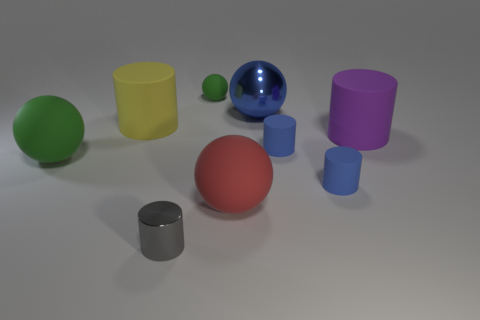Could you tell me the number of cylindrical objects and describe their appearance? There are five cylindrical objects in the image, each displaying a circular base and elongated sides. The cylinders vary in color - one is gray, one is yellow, one is purple, and two are blue, with one of the blue cylinders appearing in a smaller size than the others. Do all of these cylinders have the same height? No, the cylinders display a variety of heights. The yellow and the purple cylinders are taller, while the gray and the two blue ones are shorter, with the smaller blue cylinder being the shortest amongst them all. 